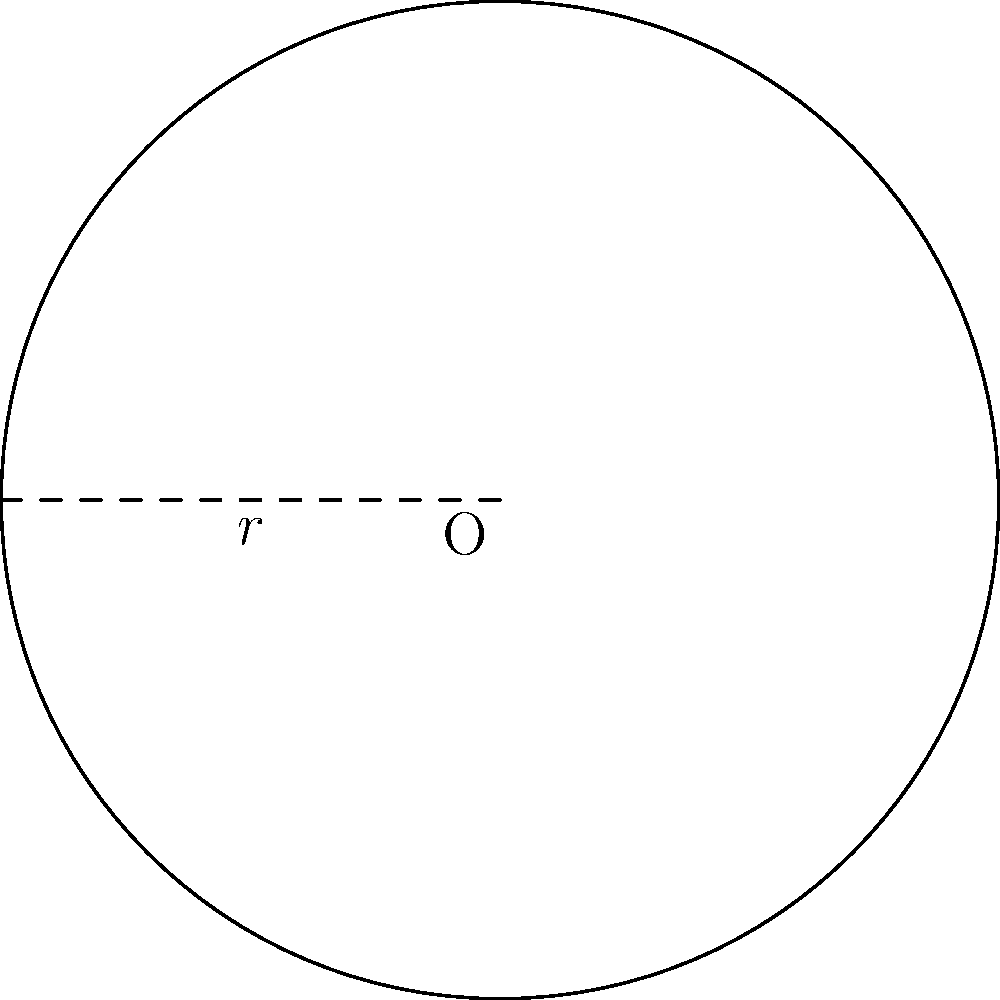As a representative for a mobile accessories company, you're designing a wireless charging pad for HTC devices. The circular pad has a radius of 6 cm. What is the total surface area of the charging pad in square centimeters? To find the area of a circular wireless charging pad, we need to use the formula for the area of a circle:

$$A = \pi r^2$$

Where:
$A$ = area of the circle
$\pi$ = pi (approximately 3.14159)
$r$ = radius of the circle

Given:
Radius $(r) = 6$ cm

Step 1: Substitute the given radius into the formula
$$A = \pi (6\text{ cm})^2$$

Step 2: Calculate the square of the radius
$$A = \pi (36\text{ cm}^2)$$

Step 3: Multiply by π
$$A = 113.10\text{ cm}^2$$ (rounded to two decimal places)

Therefore, the total surface area of the circular wireless charging pad is approximately 113.10 square centimeters.
Answer: 113.10 cm² 